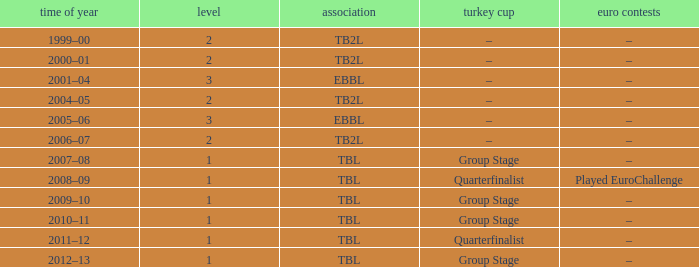Season of 2012–13 is what league? TBL. 